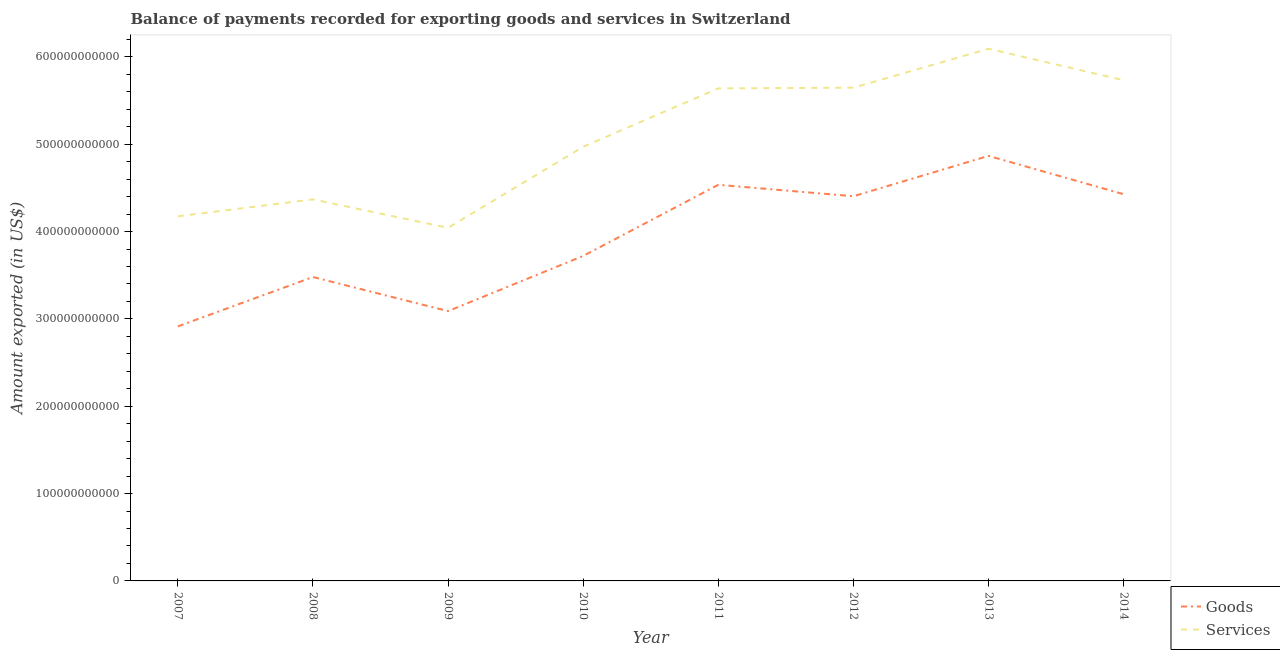Is the number of lines equal to the number of legend labels?
Make the answer very short. Yes. What is the amount of goods exported in 2013?
Give a very brief answer. 4.87e+11. Across all years, what is the maximum amount of services exported?
Your answer should be compact. 6.09e+11. Across all years, what is the minimum amount of goods exported?
Your response must be concise. 2.91e+11. In which year was the amount of goods exported maximum?
Give a very brief answer. 2013. What is the total amount of services exported in the graph?
Provide a succinct answer. 4.07e+12. What is the difference between the amount of goods exported in 2008 and that in 2012?
Your answer should be compact. -9.25e+1. What is the difference between the amount of services exported in 2010 and the amount of goods exported in 2008?
Offer a very short reply. 1.49e+11. What is the average amount of services exported per year?
Offer a very short reply. 5.08e+11. In the year 2010, what is the difference between the amount of services exported and amount of goods exported?
Provide a succinct answer. 1.25e+11. What is the ratio of the amount of services exported in 2007 to that in 2009?
Offer a very short reply. 1.03. Is the amount of goods exported in 2008 less than that in 2010?
Make the answer very short. Yes. Is the difference between the amount of services exported in 2010 and 2012 greater than the difference between the amount of goods exported in 2010 and 2012?
Provide a succinct answer. Yes. What is the difference between the highest and the second highest amount of services exported?
Ensure brevity in your answer.  3.60e+1. What is the difference between the highest and the lowest amount of services exported?
Keep it short and to the point. 2.05e+11. In how many years, is the amount of goods exported greater than the average amount of goods exported taken over all years?
Provide a succinct answer. 4. Does the amount of goods exported monotonically increase over the years?
Offer a very short reply. No. Is the amount of goods exported strictly greater than the amount of services exported over the years?
Make the answer very short. No. Is the amount of services exported strictly less than the amount of goods exported over the years?
Your response must be concise. No. How many years are there in the graph?
Keep it short and to the point. 8. What is the difference between two consecutive major ticks on the Y-axis?
Your answer should be very brief. 1.00e+11. Are the values on the major ticks of Y-axis written in scientific E-notation?
Your answer should be very brief. No. How many legend labels are there?
Keep it short and to the point. 2. What is the title of the graph?
Provide a short and direct response. Balance of payments recorded for exporting goods and services in Switzerland. Does "Rural Population" appear as one of the legend labels in the graph?
Provide a short and direct response. No. What is the label or title of the Y-axis?
Offer a terse response. Amount exported (in US$). What is the Amount exported (in US$) in Goods in 2007?
Make the answer very short. 2.91e+11. What is the Amount exported (in US$) of Services in 2007?
Make the answer very short. 4.17e+11. What is the Amount exported (in US$) in Goods in 2008?
Ensure brevity in your answer.  3.48e+11. What is the Amount exported (in US$) in Services in 2008?
Make the answer very short. 4.37e+11. What is the Amount exported (in US$) of Goods in 2009?
Offer a terse response. 3.09e+11. What is the Amount exported (in US$) in Services in 2009?
Your answer should be very brief. 4.04e+11. What is the Amount exported (in US$) of Goods in 2010?
Provide a succinct answer. 3.72e+11. What is the Amount exported (in US$) in Services in 2010?
Your response must be concise. 4.97e+11. What is the Amount exported (in US$) of Goods in 2011?
Offer a terse response. 4.54e+11. What is the Amount exported (in US$) in Services in 2011?
Offer a terse response. 5.64e+11. What is the Amount exported (in US$) in Goods in 2012?
Make the answer very short. 4.40e+11. What is the Amount exported (in US$) in Services in 2012?
Your answer should be compact. 5.65e+11. What is the Amount exported (in US$) in Goods in 2013?
Your answer should be compact. 4.87e+11. What is the Amount exported (in US$) in Services in 2013?
Provide a succinct answer. 6.09e+11. What is the Amount exported (in US$) of Goods in 2014?
Make the answer very short. 4.43e+11. What is the Amount exported (in US$) in Services in 2014?
Provide a short and direct response. 5.73e+11. Across all years, what is the maximum Amount exported (in US$) in Goods?
Make the answer very short. 4.87e+11. Across all years, what is the maximum Amount exported (in US$) in Services?
Keep it short and to the point. 6.09e+11. Across all years, what is the minimum Amount exported (in US$) of Goods?
Provide a succinct answer. 2.91e+11. Across all years, what is the minimum Amount exported (in US$) of Services?
Ensure brevity in your answer.  4.04e+11. What is the total Amount exported (in US$) of Goods in the graph?
Give a very brief answer. 3.14e+12. What is the total Amount exported (in US$) of Services in the graph?
Provide a succinct answer. 4.07e+12. What is the difference between the Amount exported (in US$) in Goods in 2007 and that in 2008?
Ensure brevity in your answer.  -5.65e+1. What is the difference between the Amount exported (in US$) in Services in 2007 and that in 2008?
Your answer should be compact. -1.94e+1. What is the difference between the Amount exported (in US$) in Goods in 2007 and that in 2009?
Ensure brevity in your answer.  -1.75e+1. What is the difference between the Amount exported (in US$) of Services in 2007 and that in 2009?
Offer a terse response. 1.32e+1. What is the difference between the Amount exported (in US$) in Goods in 2007 and that in 2010?
Provide a short and direct response. -8.07e+1. What is the difference between the Amount exported (in US$) of Services in 2007 and that in 2010?
Provide a succinct answer. -7.96e+1. What is the difference between the Amount exported (in US$) of Goods in 2007 and that in 2011?
Your response must be concise. -1.62e+11. What is the difference between the Amount exported (in US$) in Services in 2007 and that in 2011?
Offer a very short reply. -1.46e+11. What is the difference between the Amount exported (in US$) in Goods in 2007 and that in 2012?
Your answer should be very brief. -1.49e+11. What is the difference between the Amount exported (in US$) in Services in 2007 and that in 2012?
Offer a terse response. -1.47e+11. What is the difference between the Amount exported (in US$) of Goods in 2007 and that in 2013?
Give a very brief answer. -1.95e+11. What is the difference between the Amount exported (in US$) of Services in 2007 and that in 2013?
Keep it short and to the point. -1.92e+11. What is the difference between the Amount exported (in US$) of Goods in 2007 and that in 2014?
Your answer should be very brief. -1.51e+11. What is the difference between the Amount exported (in US$) of Services in 2007 and that in 2014?
Ensure brevity in your answer.  -1.56e+11. What is the difference between the Amount exported (in US$) of Goods in 2008 and that in 2009?
Give a very brief answer. 3.91e+1. What is the difference between the Amount exported (in US$) in Services in 2008 and that in 2009?
Give a very brief answer. 3.26e+1. What is the difference between the Amount exported (in US$) of Goods in 2008 and that in 2010?
Provide a short and direct response. -2.42e+1. What is the difference between the Amount exported (in US$) of Services in 2008 and that in 2010?
Your answer should be compact. -6.02e+1. What is the difference between the Amount exported (in US$) of Goods in 2008 and that in 2011?
Offer a very short reply. -1.06e+11. What is the difference between the Amount exported (in US$) of Services in 2008 and that in 2011?
Keep it short and to the point. -1.27e+11. What is the difference between the Amount exported (in US$) in Goods in 2008 and that in 2012?
Offer a very short reply. -9.25e+1. What is the difference between the Amount exported (in US$) in Services in 2008 and that in 2012?
Your answer should be very brief. -1.28e+11. What is the difference between the Amount exported (in US$) of Goods in 2008 and that in 2013?
Provide a short and direct response. -1.39e+11. What is the difference between the Amount exported (in US$) in Services in 2008 and that in 2013?
Offer a very short reply. -1.72e+11. What is the difference between the Amount exported (in US$) in Goods in 2008 and that in 2014?
Give a very brief answer. -9.48e+1. What is the difference between the Amount exported (in US$) of Services in 2008 and that in 2014?
Keep it short and to the point. -1.36e+11. What is the difference between the Amount exported (in US$) of Goods in 2009 and that in 2010?
Make the answer very short. -6.32e+1. What is the difference between the Amount exported (in US$) of Services in 2009 and that in 2010?
Offer a terse response. -9.28e+1. What is the difference between the Amount exported (in US$) of Goods in 2009 and that in 2011?
Provide a succinct answer. -1.45e+11. What is the difference between the Amount exported (in US$) in Services in 2009 and that in 2011?
Provide a succinct answer. -1.60e+11. What is the difference between the Amount exported (in US$) in Goods in 2009 and that in 2012?
Your response must be concise. -1.32e+11. What is the difference between the Amount exported (in US$) of Services in 2009 and that in 2012?
Ensure brevity in your answer.  -1.60e+11. What is the difference between the Amount exported (in US$) of Goods in 2009 and that in 2013?
Ensure brevity in your answer.  -1.78e+11. What is the difference between the Amount exported (in US$) of Services in 2009 and that in 2013?
Provide a short and direct response. -2.05e+11. What is the difference between the Amount exported (in US$) of Goods in 2009 and that in 2014?
Your answer should be compact. -1.34e+11. What is the difference between the Amount exported (in US$) in Services in 2009 and that in 2014?
Your response must be concise. -1.69e+11. What is the difference between the Amount exported (in US$) of Goods in 2010 and that in 2011?
Provide a short and direct response. -8.14e+1. What is the difference between the Amount exported (in US$) in Services in 2010 and that in 2011?
Keep it short and to the point. -6.68e+1. What is the difference between the Amount exported (in US$) of Goods in 2010 and that in 2012?
Your answer should be compact. -6.83e+1. What is the difference between the Amount exported (in US$) in Services in 2010 and that in 2012?
Provide a succinct answer. -6.77e+1. What is the difference between the Amount exported (in US$) in Goods in 2010 and that in 2013?
Keep it short and to the point. -1.15e+11. What is the difference between the Amount exported (in US$) in Services in 2010 and that in 2013?
Your answer should be compact. -1.12e+11. What is the difference between the Amount exported (in US$) of Goods in 2010 and that in 2014?
Provide a succinct answer. -7.06e+1. What is the difference between the Amount exported (in US$) in Services in 2010 and that in 2014?
Your answer should be very brief. -7.62e+1. What is the difference between the Amount exported (in US$) of Goods in 2011 and that in 2012?
Your response must be concise. 1.31e+1. What is the difference between the Amount exported (in US$) in Services in 2011 and that in 2012?
Offer a very short reply. -8.21e+08. What is the difference between the Amount exported (in US$) in Goods in 2011 and that in 2013?
Make the answer very short. -3.31e+1. What is the difference between the Amount exported (in US$) in Services in 2011 and that in 2013?
Your response must be concise. -4.54e+1. What is the difference between the Amount exported (in US$) of Goods in 2011 and that in 2014?
Your response must be concise. 1.08e+1. What is the difference between the Amount exported (in US$) of Services in 2011 and that in 2014?
Offer a very short reply. -9.35e+09. What is the difference between the Amount exported (in US$) of Goods in 2012 and that in 2013?
Ensure brevity in your answer.  -4.62e+1. What is the difference between the Amount exported (in US$) in Services in 2012 and that in 2013?
Keep it short and to the point. -4.46e+1. What is the difference between the Amount exported (in US$) in Goods in 2012 and that in 2014?
Make the answer very short. -2.28e+09. What is the difference between the Amount exported (in US$) of Services in 2012 and that in 2014?
Your answer should be compact. -8.53e+09. What is the difference between the Amount exported (in US$) in Goods in 2013 and that in 2014?
Keep it short and to the point. 4.39e+1. What is the difference between the Amount exported (in US$) of Services in 2013 and that in 2014?
Make the answer very short. 3.60e+1. What is the difference between the Amount exported (in US$) of Goods in 2007 and the Amount exported (in US$) of Services in 2008?
Offer a terse response. -1.45e+11. What is the difference between the Amount exported (in US$) in Goods in 2007 and the Amount exported (in US$) in Services in 2009?
Your answer should be very brief. -1.13e+11. What is the difference between the Amount exported (in US$) of Goods in 2007 and the Amount exported (in US$) of Services in 2010?
Keep it short and to the point. -2.06e+11. What is the difference between the Amount exported (in US$) in Goods in 2007 and the Amount exported (in US$) in Services in 2011?
Make the answer very short. -2.72e+11. What is the difference between the Amount exported (in US$) of Goods in 2007 and the Amount exported (in US$) of Services in 2012?
Your answer should be very brief. -2.73e+11. What is the difference between the Amount exported (in US$) in Goods in 2007 and the Amount exported (in US$) in Services in 2013?
Offer a terse response. -3.18e+11. What is the difference between the Amount exported (in US$) of Goods in 2007 and the Amount exported (in US$) of Services in 2014?
Provide a succinct answer. -2.82e+11. What is the difference between the Amount exported (in US$) of Goods in 2008 and the Amount exported (in US$) of Services in 2009?
Provide a short and direct response. -5.63e+1. What is the difference between the Amount exported (in US$) in Goods in 2008 and the Amount exported (in US$) in Services in 2010?
Your answer should be very brief. -1.49e+11. What is the difference between the Amount exported (in US$) of Goods in 2008 and the Amount exported (in US$) of Services in 2011?
Make the answer very short. -2.16e+11. What is the difference between the Amount exported (in US$) of Goods in 2008 and the Amount exported (in US$) of Services in 2012?
Ensure brevity in your answer.  -2.17e+11. What is the difference between the Amount exported (in US$) of Goods in 2008 and the Amount exported (in US$) of Services in 2013?
Keep it short and to the point. -2.61e+11. What is the difference between the Amount exported (in US$) of Goods in 2008 and the Amount exported (in US$) of Services in 2014?
Your response must be concise. -2.25e+11. What is the difference between the Amount exported (in US$) of Goods in 2009 and the Amount exported (in US$) of Services in 2010?
Offer a terse response. -1.88e+11. What is the difference between the Amount exported (in US$) in Goods in 2009 and the Amount exported (in US$) in Services in 2011?
Your answer should be very brief. -2.55e+11. What is the difference between the Amount exported (in US$) in Goods in 2009 and the Amount exported (in US$) in Services in 2012?
Your response must be concise. -2.56e+11. What is the difference between the Amount exported (in US$) of Goods in 2009 and the Amount exported (in US$) of Services in 2013?
Your answer should be compact. -3.00e+11. What is the difference between the Amount exported (in US$) of Goods in 2009 and the Amount exported (in US$) of Services in 2014?
Give a very brief answer. -2.64e+11. What is the difference between the Amount exported (in US$) in Goods in 2010 and the Amount exported (in US$) in Services in 2011?
Provide a short and direct response. -1.92e+11. What is the difference between the Amount exported (in US$) of Goods in 2010 and the Amount exported (in US$) of Services in 2012?
Give a very brief answer. -1.93e+11. What is the difference between the Amount exported (in US$) of Goods in 2010 and the Amount exported (in US$) of Services in 2013?
Give a very brief answer. -2.37e+11. What is the difference between the Amount exported (in US$) of Goods in 2010 and the Amount exported (in US$) of Services in 2014?
Keep it short and to the point. -2.01e+11. What is the difference between the Amount exported (in US$) in Goods in 2011 and the Amount exported (in US$) in Services in 2012?
Provide a succinct answer. -1.11e+11. What is the difference between the Amount exported (in US$) of Goods in 2011 and the Amount exported (in US$) of Services in 2013?
Ensure brevity in your answer.  -1.56e+11. What is the difference between the Amount exported (in US$) of Goods in 2011 and the Amount exported (in US$) of Services in 2014?
Make the answer very short. -1.20e+11. What is the difference between the Amount exported (in US$) of Goods in 2012 and the Amount exported (in US$) of Services in 2013?
Keep it short and to the point. -1.69e+11. What is the difference between the Amount exported (in US$) in Goods in 2012 and the Amount exported (in US$) in Services in 2014?
Provide a short and direct response. -1.33e+11. What is the difference between the Amount exported (in US$) of Goods in 2013 and the Amount exported (in US$) of Services in 2014?
Keep it short and to the point. -8.66e+1. What is the average Amount exported (in US$) of Goods per year?
Ensure brevity in your answer.  3.93e+11. What is the average Amount exported (in US$) of Services per year?
Ensure brevity in your answer.  5.08e+11. In the year 2007, what is the difference between the Amount exported (in US$) in Goods and Amount exported (in US$) in Services?
Make the answer very short. -1.26e+11. In the year 2008, what is the difference between the Amount exported (in US$) of Goods and Amount exported (in US$) of Services?
Your answer should be very brief. -8.89e+1. In the year 2009, what is the difference between the Amount exported (in US$) of Goods and Amount exported (in US$) of Services?
Your response must be concise. -9.54e+1. In the year 2010, what is the difference between the Amount exported (in US$) of Goods and Amount exported (in US$) of Services?
Your answer should be very brief. -1.25e+11. In the year 2011, what is the difference between the Amount exported (in US$) in Goods and Amount exported (in US$) in Services?
Your response must be concise. -1.10e+11. In the year 2012, what is the difference between the Amount exported (in US$) of Goods and Amount exported (in US$) of Services?
Your answer should be very brief. -1.24e+11. In the year 2013, what is the difference between the Amount exported (in US$) in Goods and Amount exported (in US$) in Services?
Provide a short and direct response. -1.23e+11. In the year 2014, what is the difference between the Amount exported (in US$) of Goods and Amount exported (in US$) of Services?
Make the answer very short. -1.31e+11. What is the ratio of the Amount exported (in US$) of Goods in 2007 to that in 2008?
Provide a succinct answer. 0.84. What is the ratio of the Amount exported (in US$) in Services in 2007 to that in 2008?
Provide a short and direct response. 0.96. What is the ratio of the Amount exported (in US$) of Goods in 2007 to that in 2009?
Provide a succinct answer. 0.94. What is the ratio of the Amount exported (in US$) of Services in 2007 to that in 2009?
Offer a terse response. 1.03. What is the ratio of the Amount exported (in US$) of Goods in 2007 to that in 2010?
Give a very brief answer. 0.78. What is the ratio of the Amount exported (in US$) in Services in 2007 to that in 2010?
Make the answer very short. 0.84. What is the ratio of the Amount exported (in US$) in Goods in 2007 to that in 2011?
Ensure brevity in your answer.  0.64. What is the ratio of the Amount exported (in US$) of Services in 2007 to that in 2011?
Your response must be concise. 0.74. What is the ratio of the Amount exported (in US$) in Goods in 2007 to that in 2012?
Your answer should be very brief. 0.66. What is the ratio of the Amount exported (in US$) of Services in 2007 to that in 2012?
Give a very brief answer. 0.74. What is the ratio of the Amount exported (in US$) in Goods in 2007 to that in 2013?
Your response must be concise. 0.6. What is the ratio of the Amount exported (in US$) in Services in 2007 to that in 2013?
Your answer should be compact. 0.69. What is the ratio of the Amount exported (in US$) of Goods in 2007 to that in 2014?
Your response must be concise. 0.66. What is the ratio of the Amount exported (in US$) of Services in 2007 to that in 2014?
Keep it short and to the point. 0.73. What is the ratio of the Amount exported (in US$) in Goods in 2008 to that in 2009?
Ensure brevity in your answer.  1.13. What is the ratio of the Amount exported (in US$) in Services in 2008 to that in 2009?
Your answer should be compact. 1.08. What is the ratio of the Amount exported (in US$) of Goods in 2008 to that in 2010?
Provide a short and direct response. 0.94. What is the ratio of the Amount exported (in US$) in Services in 2008 to that in 2010?
Your answer should be compact. 0.88. What is the ratio of the Amount exported (in US$) in Goods in 2008 to that in 2011?
Your response must be concise. 0.77. What is the ratio of the Amount exported (in US$) of Services in 2008 to that in 2011?
Your answer should be very brief. 0.77. What is the ratio of the Amount exported (in US$) of Goods in 2008 to that in 2012?
Ensure brevity in your answer.  0.79. What is the ratio of the Amount exported (in US$) of Services in 2008 to that in 2012?
Offer a terse response. 0.77. What is the ratio of the Amount exported (in US$) in Goods in 2008 to that in 2013?
Your response must be concise. 0.71. What is the ratio of the Amount exported (in US$) of Services in 2008 to that in 2013?
Provide a succinct answer. 0.72. What is the ratio of the Amount exported (in US$) of Goods in 2008 to that in 2014?
Your response must be concise. 0.79. What is the ratio of the Amount exported (in US$) in Services in 2008 to that in 2014?
Your answer should be compact. 0.76. What is the ratio of the Amount exported (in US$) of Goods in 2009 to that in 2010?
Your response must be concise. 0.83. What is the ratio of the Amount exported (in US$) in Services in 2009 to that in 2010?
Give a very brief answer. 0.81. What is the ratio of the Amount exported (in US$) in Goods in 2009 to that in 2011?
Provide a succinct answer. 0.68. What is the ratio of the Amount exported (in US$) of Services in 2009 to that in 2011?
Keep it short and to the point. 0.72. What is the ratio of the Amount exported (in US$) in Goods in 2009 to that in 2012?
Your answer should be compact. 0.7. What is the ratio of the Amount exported (in US$) in Services in 2009 to that in 2012?
Your answer should be very brief. 0.72. What is the ratio of the Amount exported (in US$) of Goods in 2009 to that in 2013?
Make the answer very short. 0.63. What is the ratio of the Amount exported (in US$) of Services in 2009 to that in 2013?
Your answer should be very brief. 0.66. What is the ratio of the Amount exported (in US$) in Goods in 2009 to that in 2014?
Provide a short and direct response. 0.7. What is the ratio of the Amount exported (in US$) of Services in 2009 to that in 2014?
Provide a succinct answer. 0.71. What is the ratio of the Amount exported (in US$) in Goods in 2010 to that in 2011?
Keep it short and to the point. 0.82. What is the ratio of the Amount exported (in US$) of Services in 2010 to that in 2011?
Provide a short and direct response. 0.88. What is the ratio of the Amount exported (in US$) in Goods in 2010 to that in 2012?
Your answer should be very brief. 0.84. What is the ratio of the Amount exported (in US$) in Services in 2010 to that in 2012?
Provide a short and direct response. 0.88. What is the ratio of the Amount exported (in US$) of Goods in 2010 to that in 2013?
Provide a short and direct response. 0.76. What is the ratio of the Amount exported (in US$) of Services in 2010 to that in 2013?
Keep it short and to the point. 0.82. What is the ratio of the Amount exported (in US$) of Goods in 2010 to that in 2014?
Ensure brevity in your answer.  0.84. What is the ratio of the Amount exported (in US$) of Services in 2010 to that in 2014?
Provide a short and direct response. 0.87. What is the ratio of the Amount exported (in US$) of Goods in 2011 to that in 2012?
Your response must be concise. 1.03. What is the ratio of the Amount exported (in US$) of Goods in 2011 to that in 2013?
Provide a succinct answer. 0.93. What is the ratio of the Amount exported (in US$) in Services in 2011 to that in 2013?
Your answer should be very brief. 0.93. What is the ratio of the Amount exported (in US$) of Goods in 2011 to that in 2014?
Offer a terse response. 1.02. What is the ratio of the Amount exported (in US$) in Services in 2011 to that in 2014?
Your response must be concise. 0.98. What is the ratio of the Amount exported (in US$) in Goods in 2012 to that in 2013?
Make the answer very short. 0.91. What is the ratio of the Amount exported (in US$) of Services in 2012 to that in 2013?
Provide a succinct answer. 0.93. What is the ratio of the Amount exported (in US$) in Goods in 2012 to that in 2014?
Offer a very short reply. 0.99. What is the ratio of the Amount exported (in US$) in Services in 2012 to that in 2014?
Ensure brevity in your answer.  0.99. What is the ratio of the Amount exported (in US$) of Goods in 2013 to that in 2014?
Offer a terse response. 1.1. What is the ratio of the Amount exported (in US$) of Services in 2013 to that in 2014?
Offer a terse response. 1.06. What is the difference between the highest and the second highest Amount exported (in US$) of Goods?
Provide a short and direct response. 3.31e+1. What is the difference between the highest and the second highest Amount exported (in US$) of Services?
Give a very brief answer. 3.60e+1. What is the difference between the highest and the lowest Amount exported (in US$) in Goods?
Provide a succinct answer. 1.95e+11. What is the difference between the highest and the lowest Amount exported (in US$) in Services?
Your answer should be compact. 2.05e+11. 